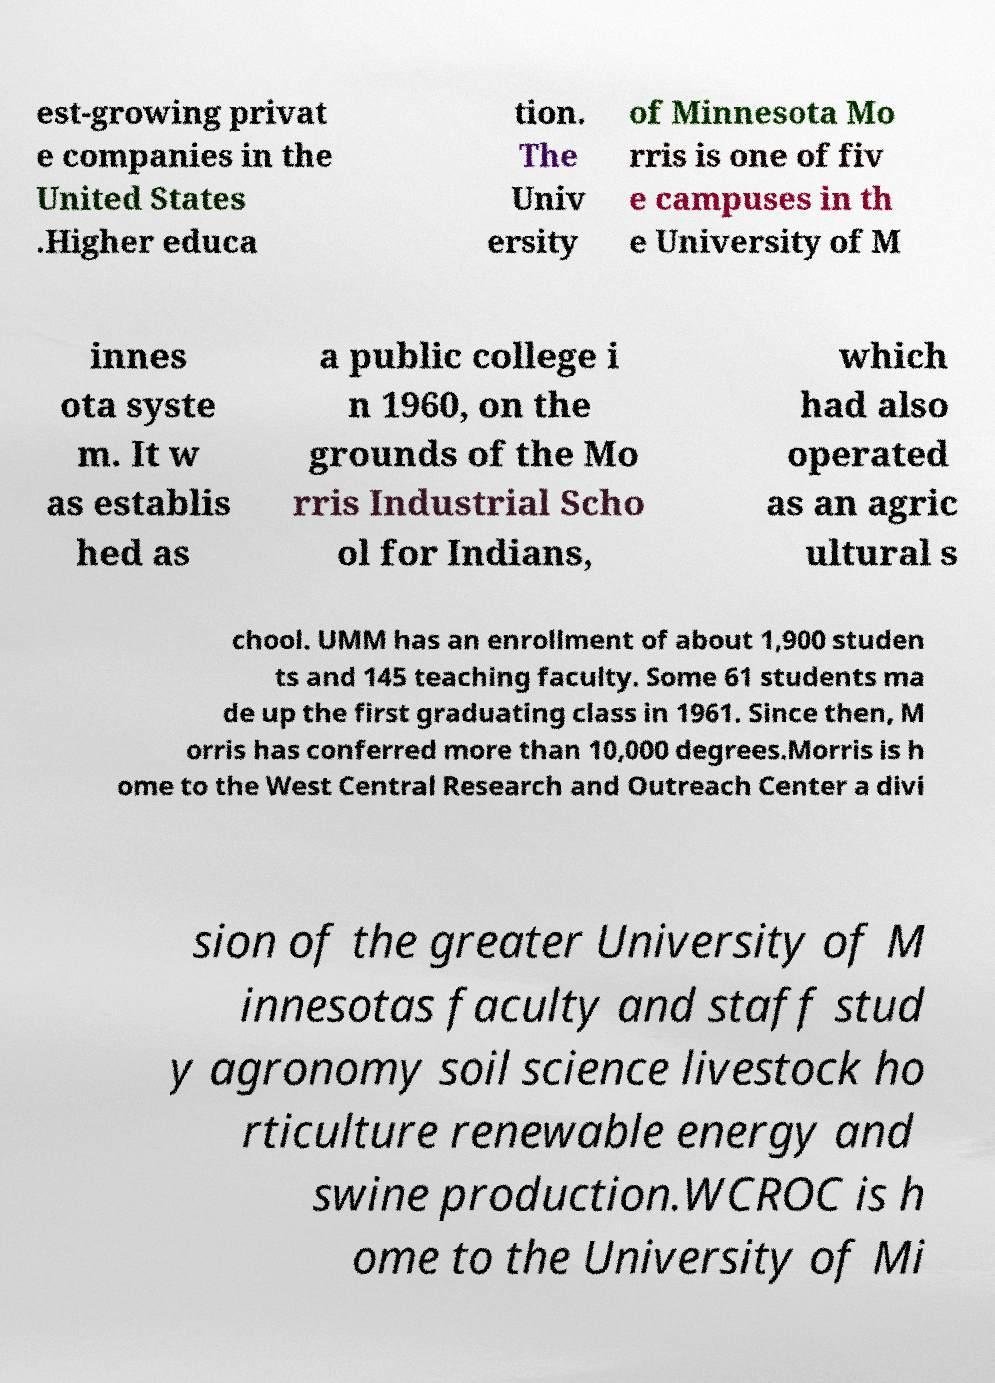Please identify and transcribe the text found in this image. est-growing privat e companies in the United States .Higher educa tion. The Univ ersity of Minnesota Mo rris is one of fiv e campuses in th e University of M innes ota syste m. It w as establis hed as a public college i n 1960, on the grounds of the Mo rris Industrial Scho ol for Indians, which had also operated as an agric ultural s chool. UMM has an enrollment of about 1,900 studen ts and 145 teaching faculty. Some 61 students ma de up the first graduating class in 1961. Since then, M orris has conferred more than 10,000 degrees.Morris is h ome to the West Central Research and Outreach Center a divi sion of the greater University of M innesotas faculty and staff stud y agronomy soil science livestock ho rticulture renewable energy and swine production.WCROC is h ome to the University of Mi 